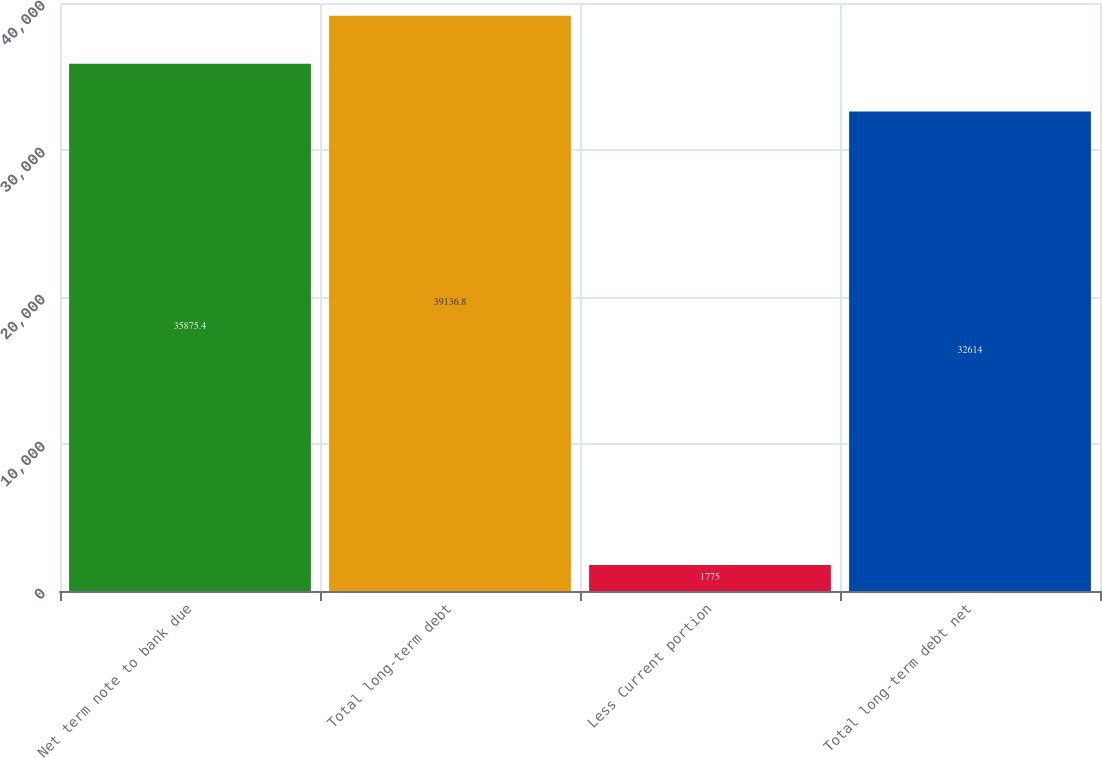<chart> <loc_0><loc_0><loc_500><loc_500><bar_chart><fcel>Net term note to bank due<fcel>Total long-term debt<fcel>Less Current portion<fcel>Total long-term debt net<nl><fcel>35875.4<fcel>39136.8<fcel>1775<fcel>32614<nl></chart> 